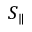Convert formula to latex. <formula><loc_0><loc_0><loc_500><loc_500>S _ { \| }</formula> 